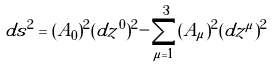<formula> <loc_0><loc_0><loc_500><loc_500>d s ^ { 2 } = ( A _ { 0 } ) ^ { 2 } ( d z ^ { 0 } ) ^ { 2 } - \sum _ { \mu = 1 } ^ { 3 } ( A _ { \mu } ) ^ { 2 } ( d z ^ { \mu } ) ^ { 2 }</formula> 